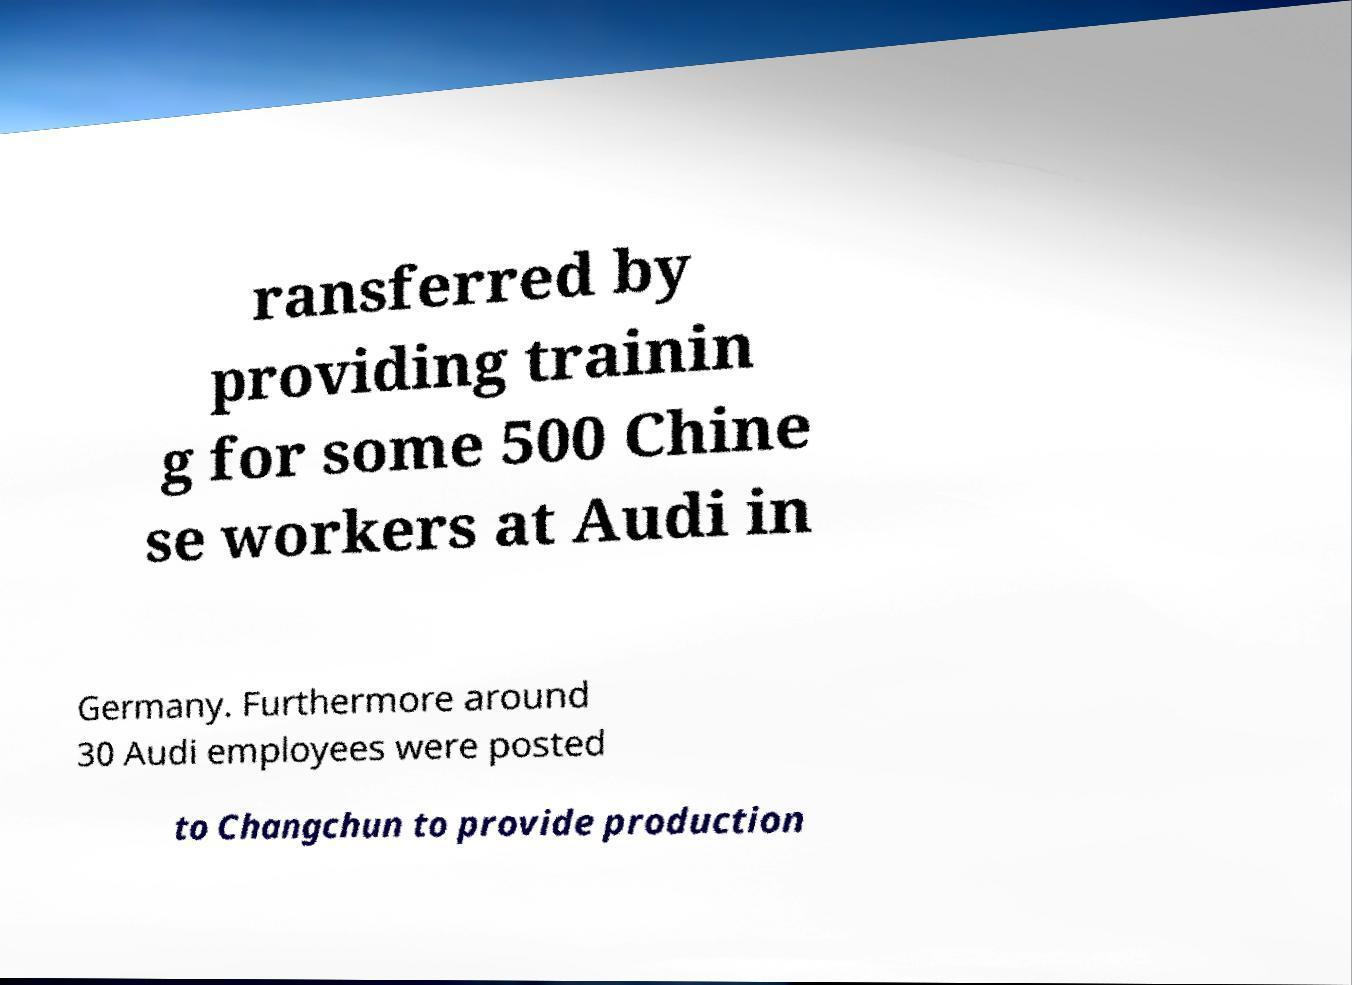Can you read and provide the text displayed in the image?This photo seems to have some interesting text. Can you extract and type it out for me? ransferred by providing trainin g for some 500 Chine se workers at Audi in Germany. Furthermore around 30 Audi employees were posted to Changchun to provide production 